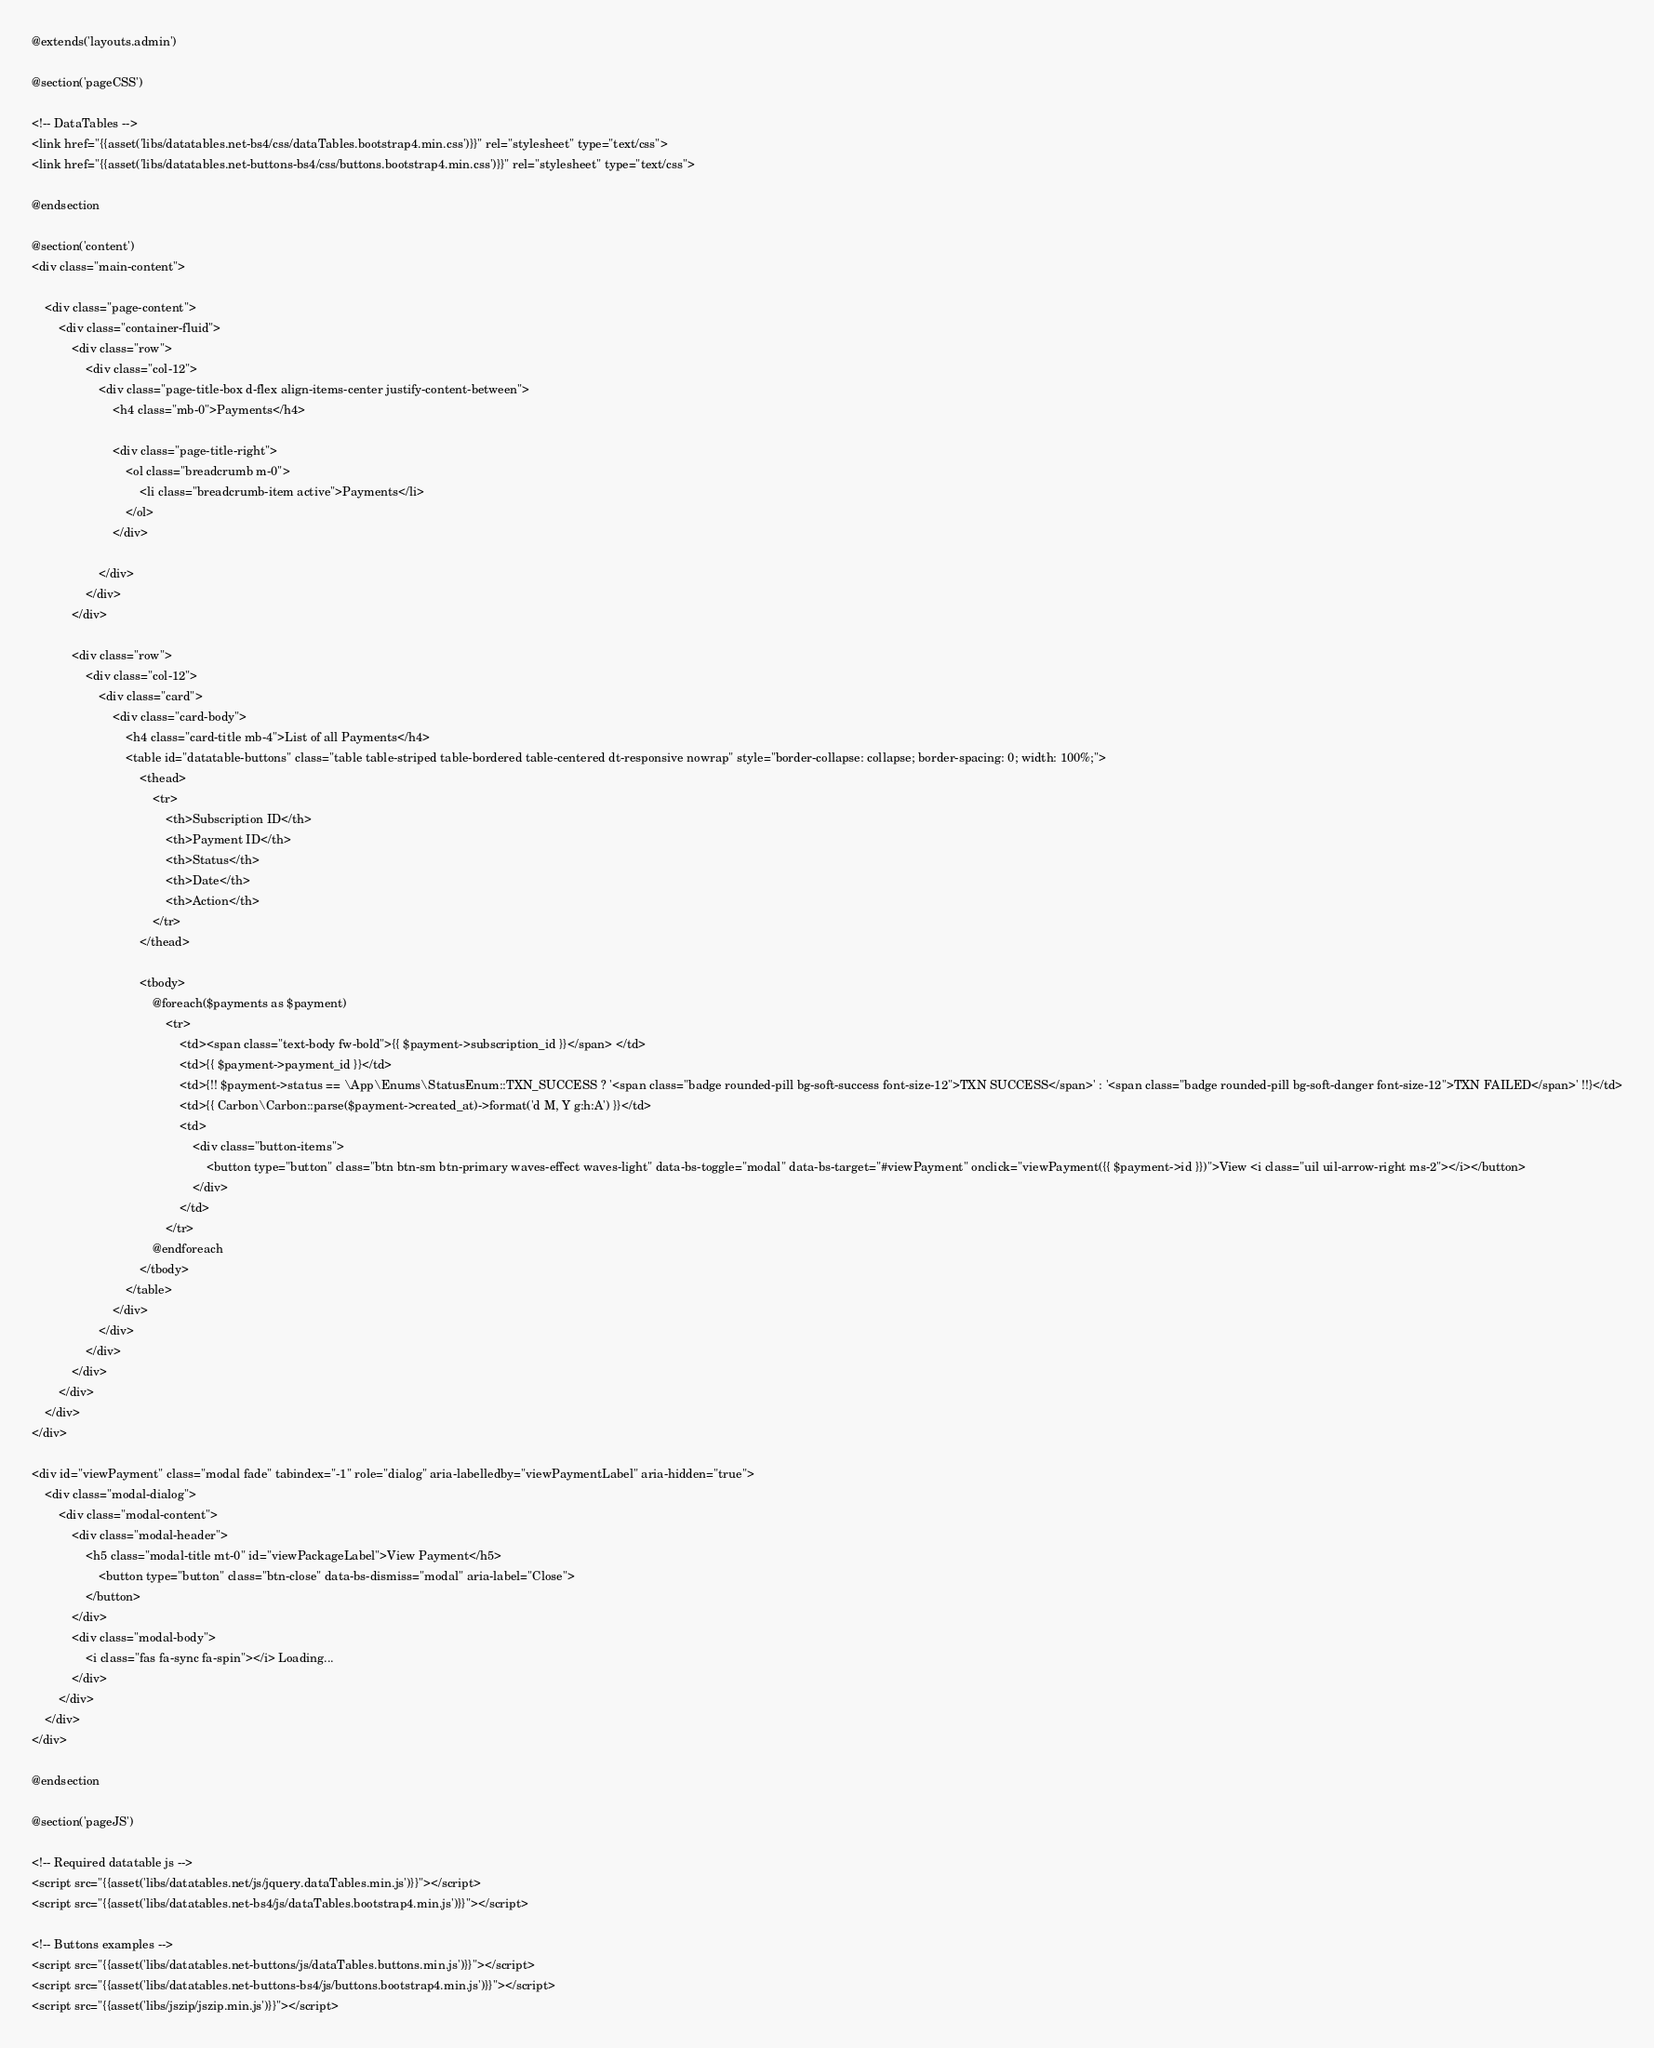<code> <loc_0><loc_0><loc_500><loc_500><_PHP_>@extends('layouts.admin')

@section('pageCSS')

<!-- DataTables -->
<link href="{{asset('libs/datatables.net-bs4/css/dataTables.bootstrap4.min.css')}}" rel="stylesheet" type="text/css">
<link href="{{asset('libs/datatables.net-buttons-bs4/css/buttons.bootstrap4.min.css')}}" rel="stylesheet" type="text/css">

@endsection

@section('content')
<div class="main-content">

    <div class="page-content">
        <div class="container-fluid">
            <div class="row">
                <div class="col-12">
                    <div class="page-title-box d-flex align-items-center justify-content-between">
                        <h4 class="mb-0">Payments</h4>

                        <div class="page-title-right">
                            <ol class="breadcrumb m-0">
                                <li class="breadcrumb-item active">Payments</li>
                            </ol>
                        </div>

                    </div>
                </div>
            </div>

            <div class="row">
                <div class="col-12">
                    <div class="card">
                        <div class="card-body">
                            <h4 class="card-title mb-4">List of all Payments</h4>
                            <table id="datatable-buttons" class="table table-striped table-bordered table-centered dt-responsive nowrap" style="border-collapse: collapse; border-spacing: 0; width: 100%;">
                                <thead>
                                    <tr>
                                        <th>Subscription ID</th>
                                        <th>Payment ID</th>
                                        <th>Status</th>
                                        <th>Date</th>
                                        <th>Action</th>
                                    </tr>
                                </thead>

                                <tbody>
                                    @foreach($payments as $payment)
                                        <tr>
                                            <td><span class="text-body fw-bold">{{ $payment->subscription_id }}</span> </td>
                                            <td>{{ $payment->payment_id }}</td>
                                            <td>{!! $payment->status == \App\Enums\StatusEnum::TXN_SUCCESS ? '<span class="badge rounded-pill bg-soft-success font-size-12">TXN SUCCESS</span>' : '<span class="badge rounded-pill bg-soft-danger font-size-12">TXN FAILED</span>' !!}</td>
                                            <td>{{ Carbon\Carbon::parse($payment->created_at)->format('d M, Y g:h:A') }}</td>
                                            <td>
                                                <div class="button-items">
                                                    <button type="button" class="btn btn-sm btn-primary waves-effect waves-light" data-bs-toggle="modal" data-bs-target="#viewPayment" onclick="viewPayment({{ $payment->id }})">View <i class="uil uil-arrow-right ms-2"></i></button>
                                                </div>
                                            </td>
                                        </tr>
                                    @endforeach
                                </tbody>
                            </table>
                        </div>
                    </div>
                </div>
            </div>
        </div>
    </div>
</div>

<div id="viewPayment" class="modal fade" tabindex="-1" role="dialog" aria-labelledby="viewPaymentLabel" aria-hidden="true">
    <div class="modal-dialog">
        <div class="modal-content">
            <div class="modal-header">
                <h5 class="modal-title mt-0" id="viewPackageLabel">View Payment</h5>
                    <button type="button" class="btn-close" data-bs-dismiss="modal" aria-label="Close">
                </button>
            </div>
            <div class="modal-body">
                <i class="fas fa-sync fa-spin"></i> Loading...
            </div>
        </div>
    </div>
</div>

@endsection

@section('pageJS')

<!-- Required datatable js -->
<script src="{{asset('libs/datatables.net/js/jquery.dataTables.min.js')}}"></script>
<script src="{{asset('libs/datatables.net-bs4/js/dataTables.bootstrap4.min.js')}}"></script>

<!-- Buttons examples -->
<script src="{{asset('libs/datatables.net-buttons/js/dataTables.buttons.min.js')}}"></script>
<script src="{{asset('libs/datatables.net-buttons-bs4/js/buttons.bootstrap4.min.js')}}"></script>
<script src="{{asset('libs/jszip/jszip.min.js')}}"></script></code> 